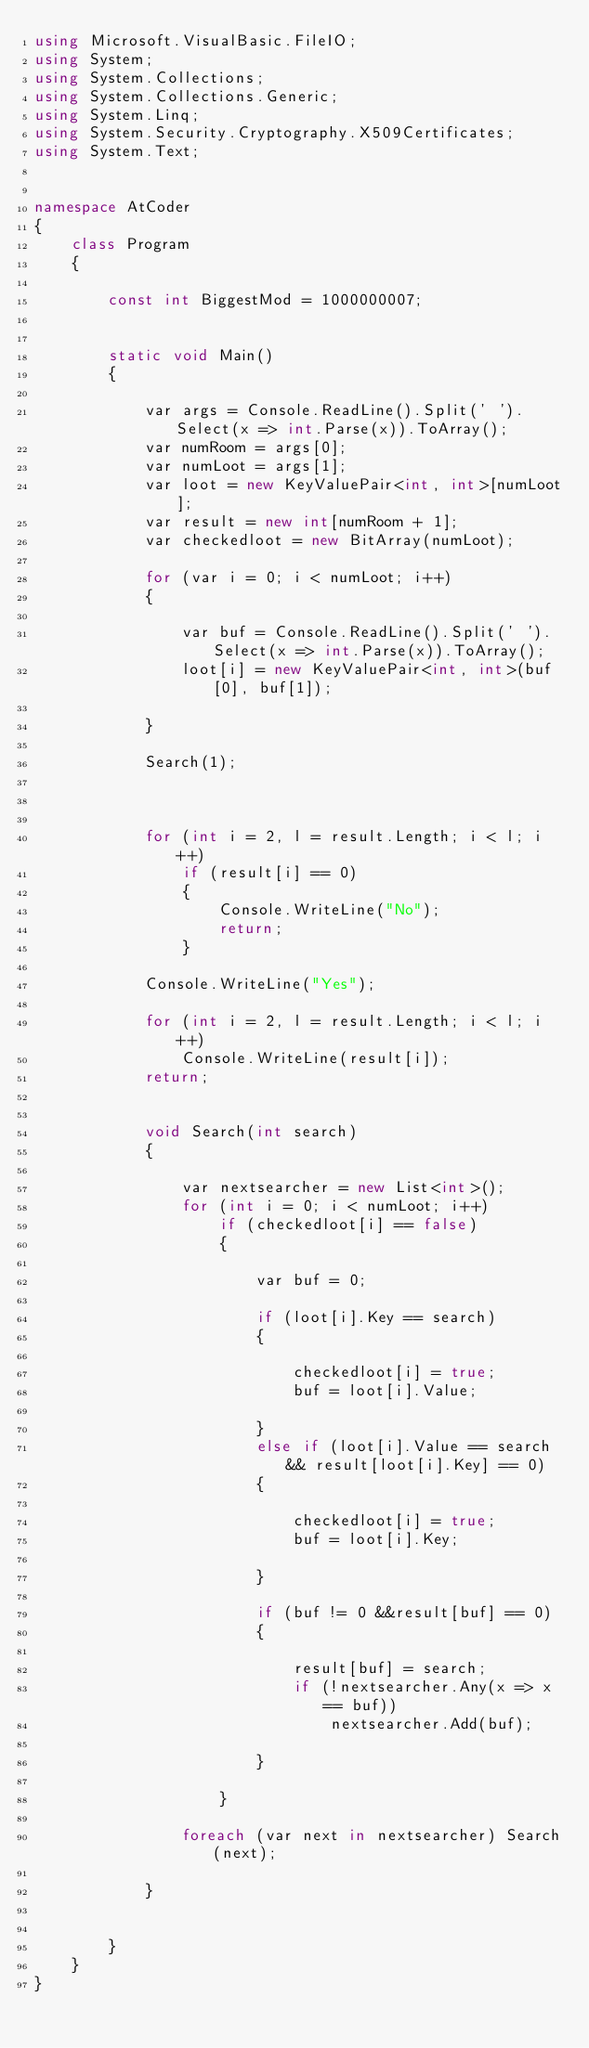<code> <loc_0><loc_0><loc_500><loc_500><_C#_>using Microsoft.VisualBasic.FileIO;
using System;
using System.Collections;
using System.Collections.Generic;
using System.Linq;
using System.Security.Cryptography.X509Certificates;
using System.Text;


namespace AtCoder
{
    class Program
    {

        const int BiggestMod = 1000000007;


        static void Main()
        {

            var args = Console.ReadLine().Split(' ').Select(x => int.Parse(x)).ToArray();
            var numRoom = args[0];
            var numLoot = args[1];
            var loot = new KeyValuePair<int, int>[numLoot];
            var result = new int[numRoom + 1];
            var checkedloot = new BitArray(numLoot);

            for (var i = 0; i < numLoot; i++)
            {

                var buf = Console.ReadLine().Split(' ').Select(x => int.Parse(x)).ToArray();
                loot[i] = new KeyValuePair<int, int>(buf[0], buf[1]);

            }

            Search(1);



            for (int i = 2, l = result.Length; i < l; i++)
                if (result[i] == 0)
                {
                    Console.WriteLine("No");
                    return;
                }

            Console.WriteLine("Yes");

            for (int i = 2, l = result.Length; i < l; i++)
                Console.WriteLine(result[i]);
            return;


            void Search(int search)
            {

                var nextsearcher = new List<int>();
                for (int i = 0; i < numLoot; i++)
                    if (checkedloot[i] == false)
                    {

                        var buf = 0;

                        if (loot[i].Key == search)
                        {

                            checkedloot[i] = true;
                            buf = loot[i].Value;

                        }
                        else if (loot[i].Value == search && result[loot[i].Key] == 0)
                        {

                            checkedloot[i] = true;
                            buf = loot[i].Key;

                        }

                        if (buf != 0 &&result[buf] == 0)
                        {

                            result[buf] = search;
                            if (!nextsearcher.Any(x => x == buf))
                                nextsearcher.Add(buf);

                        }

                    }

                foreach (var next in nextsearcher) Search(next);

            }
                

        }
    }
}
</code> 